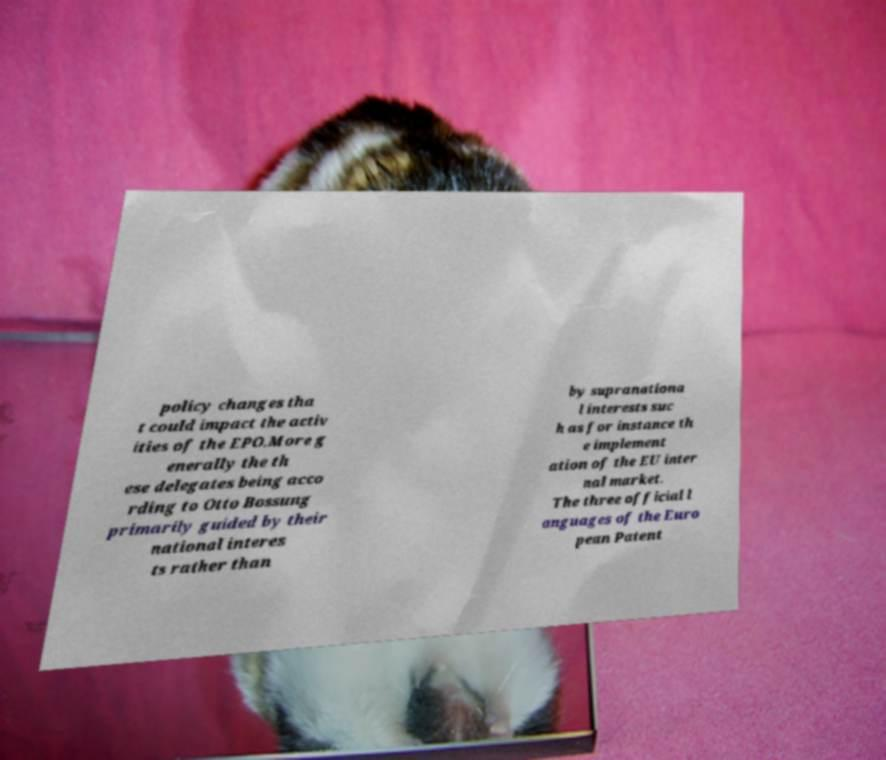Could you extract and type out the text from this image? policy changes tha t could impact the activ ities of the EPO.More g enerally the th ese delegates being acco rding to Otto Bossung primarily guided by their national interes ts rather than by supranationa l interests suc h as for instance th e implement ation of the EU inter nal market. The three official l anguages of the Euro pean Patent 